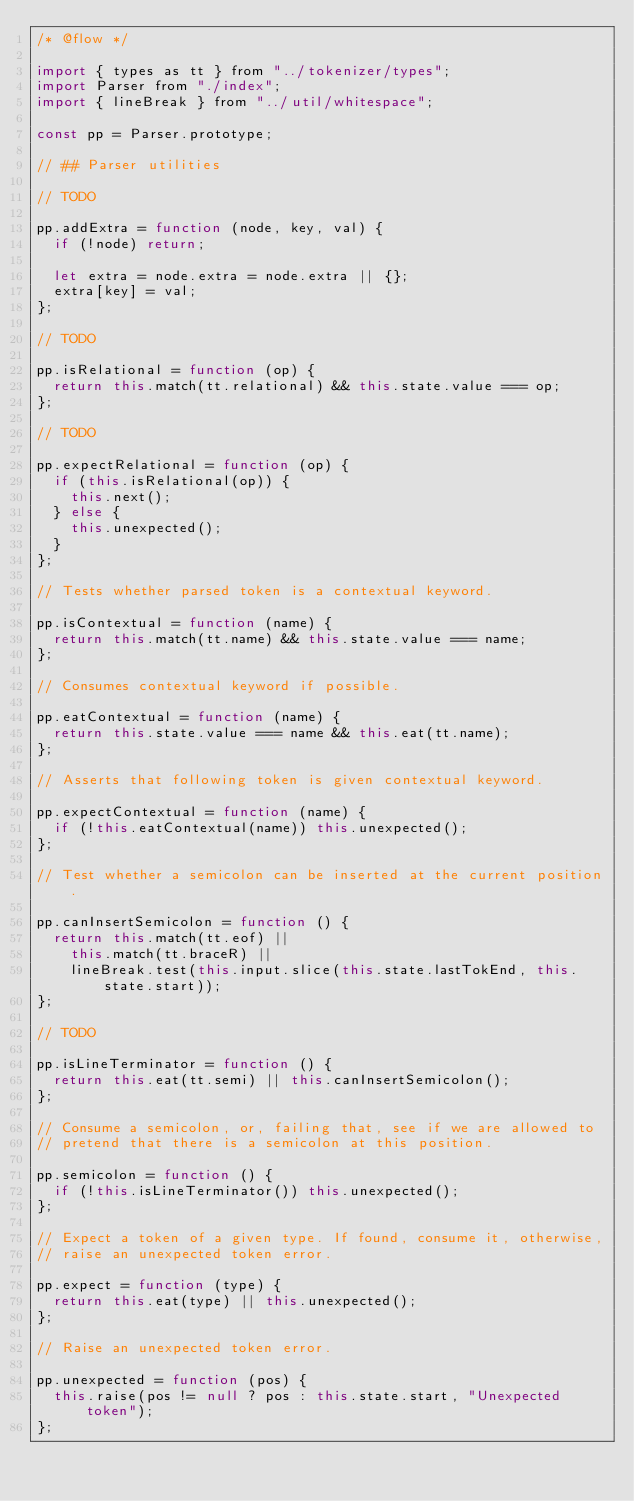<code> <loc_0><loc_0><loc_500><loc_500><_JavaScript_>/* @flow */

import { types as tt } from "../tokenizer/types";
import Parser from "./index";
import { lineBreak } from "../util/whitespace";

const pp = Parser.prototype;

// ## Parser utilities

// TODO

pp.addExtra = function (node, key, val) {
  if (!node) return;

  let extra = node.extra = node.extra || {};
  extra[key] = val;
};

// TODO

pp.isRelational = function (op) {
  return this.match(tt.relational) && this.state.value === op;
};

// TODO

pp.expectRelational = function (op) {
  if (this.isRelational(op)) {
    this.next();
  } else {
    this.unexpected();
  }
};

// Tests whether parsed token is a contextual keyword.

pp.isContextual = function (name) {
  return this.match(tt.name) && this.state.value === name;
};

// Consumes contextual keyword if possible.

pp.eatContextual = function (name) {
  return this.state.value === name && this.eat(tt.name);
};

// Asserts that following token is given contextual keyword.

pp.expectContextual = function (name) {
  if (!this.eatContextual(name)) this.unexpected();
};

// Test whether a semicolon can be inserted at the current position.

pp.canInsertSemicolon = function () {
  return this.match(tt.eof) ||
    this.match(tt.braceR) ||
    lineBreak.test(this.input.slice(this.state.lastTokEnd, this.state.start));
};

// TODO

pp.isLineTerminator = function () {
  return this.eat(tt.semi) || this.canInsertSemicolon();
};

// Consume a semicolon, or, failing that, see if we are allowed to
// pretend that there is a semicolon at this position.

pp.semicolon = function () {
  if (!this.isLineTerminator()) this.unexpected();
};

// Expect a token of a given type. If found, consume it, otherwise,
// raise an unexpected token error.

pp.expect = function (type) {
  return this.eat(type) || this.unexpected();
};

// Raise an unexpected token error.

pp.unexpected = function (pos) {
  this.raise(pos != null ? pos : this.state.start, "Unexpected token");
};
</code> 